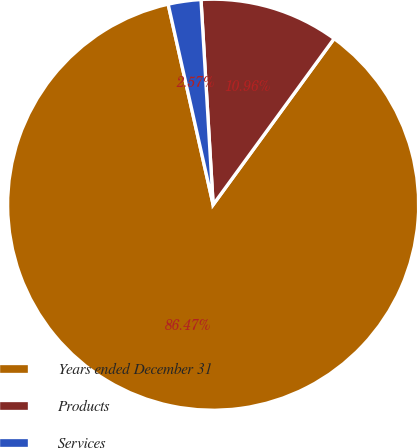<chart> <loc_0><loc_0><loc_500><loc_500><pie_chart><fcel>Years ended December 31<fcel>Products<fcel>Services<nl><fcel>86.46%<fcel>10.96%<fcel>2.57%<nl></chart> 